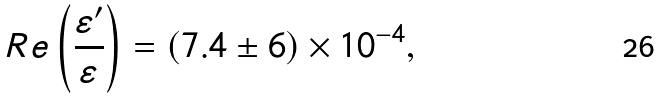Convert formula to latex. <formula><loc_0><loc_0><loc_500><loc_500>R e \left ( \frac { \varepsilon ^ { \prime } } { \varepsilon } \right ) = ( 7 . 4 \pm 6 ) \times 1 0 ^ { - 4 } , \,</formula> 